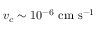<formula> <loc_0><loc_0><loc_500><loc_500>v _ { c } \sim 1 0 ^ { - 6 } \ c m \ s ^ { - 1 }</formula> 